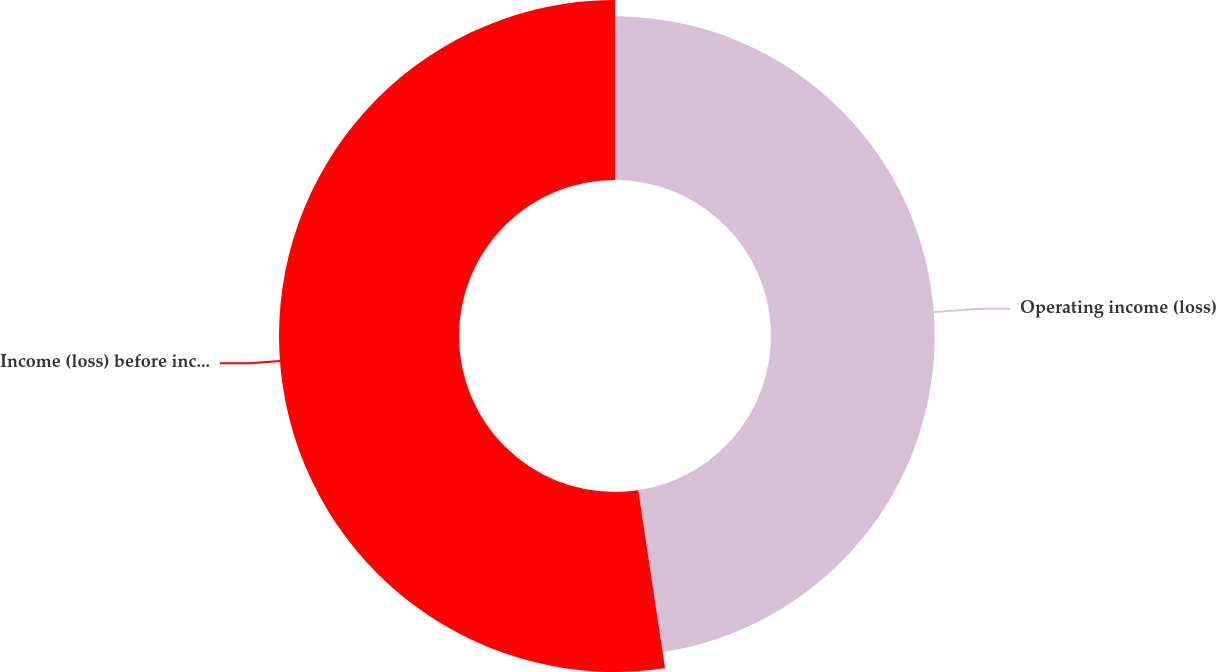<chart> <loc_0><loc_0><loc_500><loc_500><pie_chart><fcel>Operating income (loss)<fcel>Income (loss) before income<nl><fcel>47.62%<fcel>52.38%<nl></chart> 